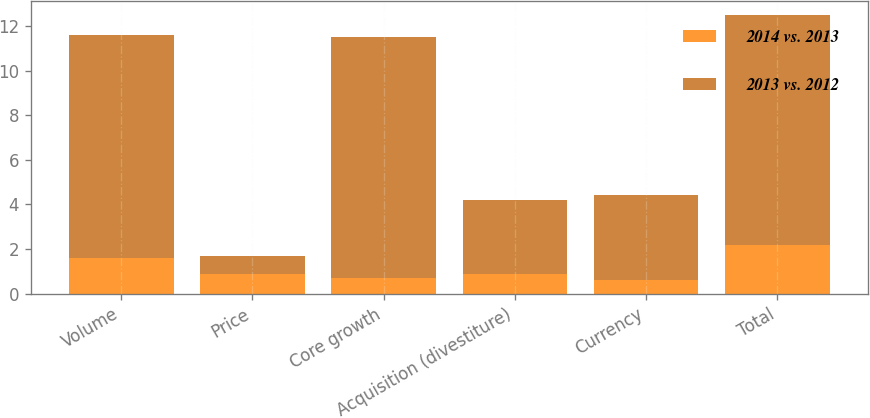Convert chart. <chart><loc_0><loc_0><loc_500><loc_500><stacked_bar_chart><ecel><fcel>Volume<fcel>Price<fcel>Core growth<fcel>Acquisition (divestiture)<fcel>Currency<fcel>Total<nl><fcel>2014 vs. 2013<fcel>1.6<fcel>0.9<fcel>0.7<fcel>0.9<fcel>0.6<fcel>2.2<nl><fcel>2013 vs. 2012<fcel>10<fcel>0.8<fcel>10.8<fcel>3.3<fcel>3.8<fcel>10.3<nl></chart> 